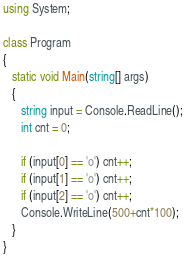Convert code to text. <code><loc_0><loc_0><loc_500><loc_500><_C#_>using System;

class Program
{
   static void Main(string[] args)
   {
      string input = Console.ReadLine();
      int cnt = 0; 
      
      if (input[0] == 'o') cnt++;
      if (input[1] == 'o') cnt++;
      if (input[2] == 'o') cnt++;
      Console.WriteLine(500+cnt*100);
   }
}
</code> 